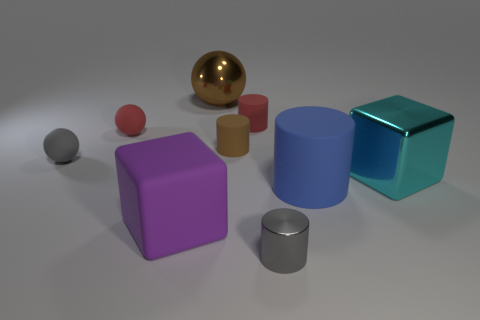Are there any objects in the image that have both a circular base and are not colored? Yes, there is one object with a circular base that is not colored; it's the grey metallic cylinder on the right side of the image. 